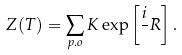Convert formula to latex. <formula><loc_0><loc_0><loc_500><loc_500>Z ( T ) = \sum _ { p . o } K \exp \left [ \frac { i } { } R \right ] .</formula> 